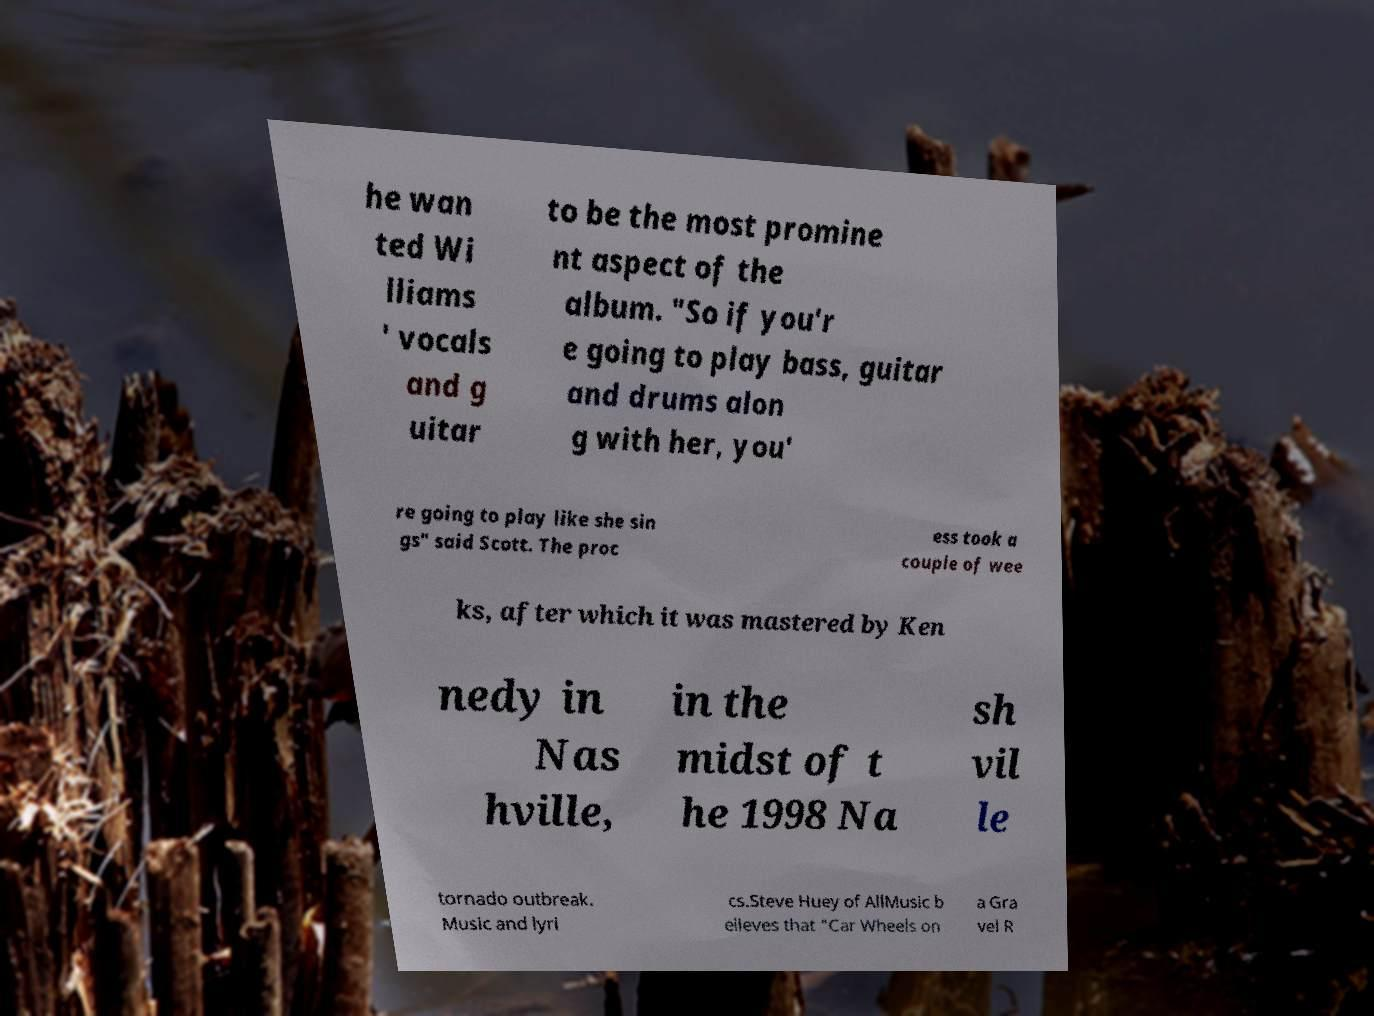Could you extract and type out the text from this image? he wan ted Wi lliams ' vocals and g uitar to be the most promine nt aspect of the album. "So if you'r e going to play bass, guitar and drums alon g with her, you' re going to play like she sin gs" said Scott. The proc ess took a couple of wee ks, after which it was mastered by Ken nedy in Nas hville, in the midst of t he 1998 Na sh vil le tornado outbreak. Music and lyri cs.Steve Huey of AllMusic b elieves that "Car Wheels on a Gra vel R 